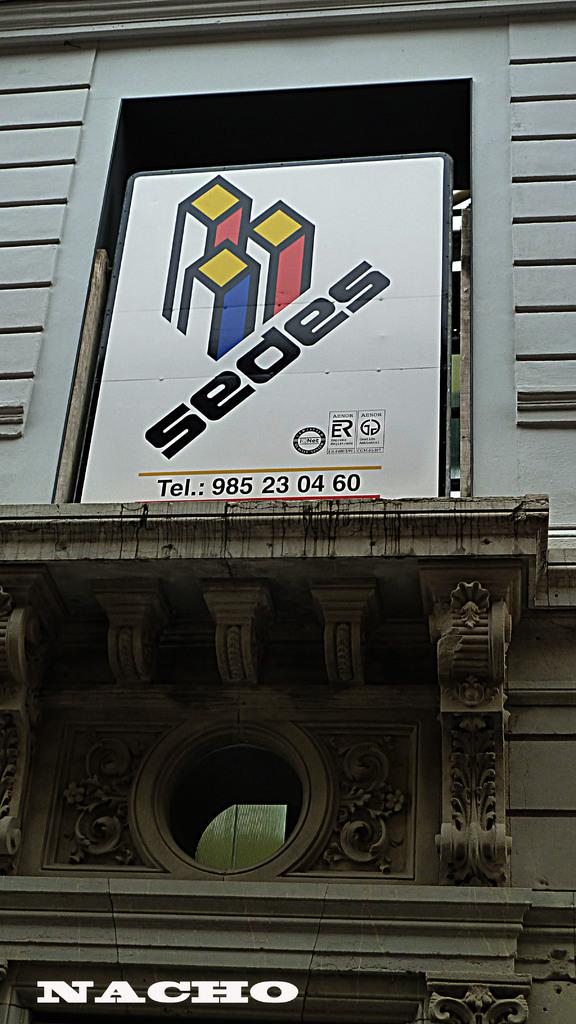What type of structure can be seen in the image? There is a wall in the image. What is attached to the wall in the image? There is a board with text in the image. What type of gun is being used by the father in the image? There is no gun or father present in the image; it only features a wall and a board with text. 